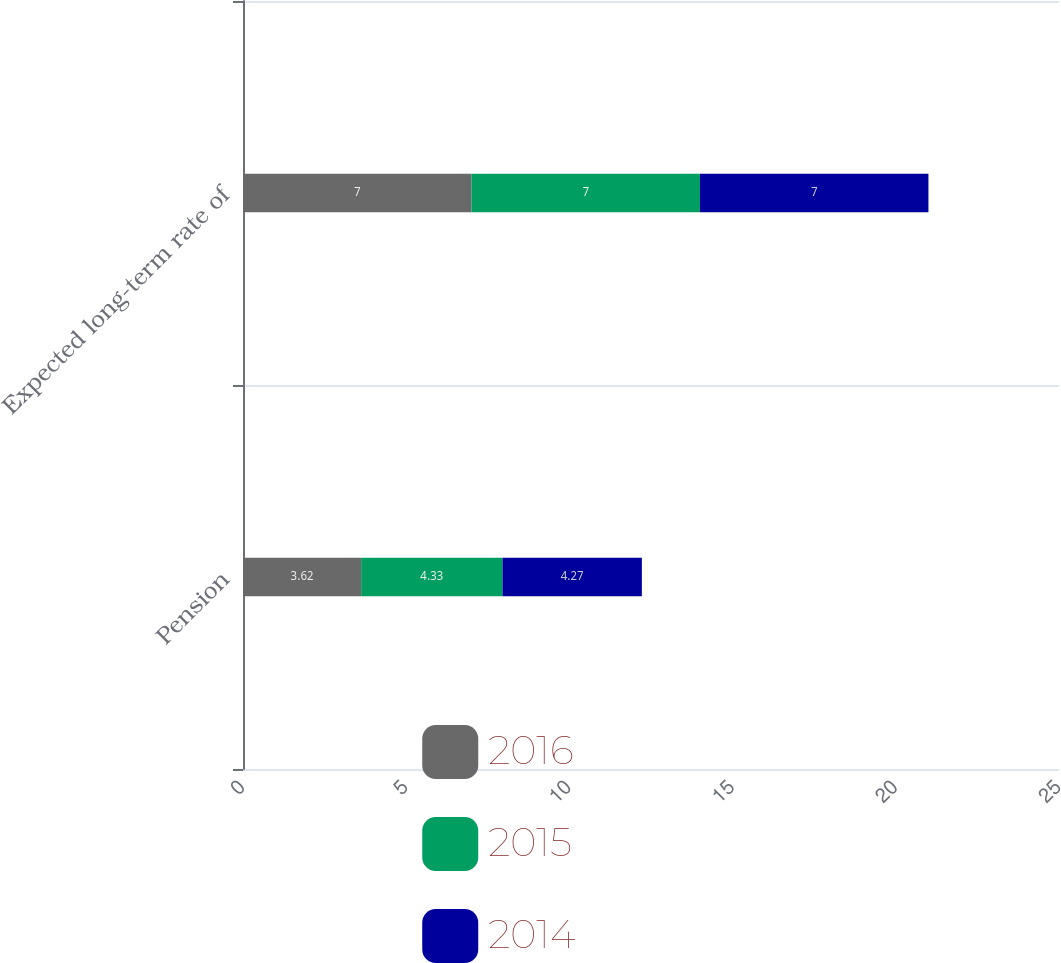<chart> <loc_0><loc_0><loc_500><loc_500><stacked_bar_chart><ecel><fcel>Pension<fcel>Expected long-term rate of<nl><fcel>2016<fcel>3.62<fcel>7<nl><fcel>2015<fcel>4.33<fcel>7<nl><fcel>2014<fcel>4.27<fcel>7<nl></chart> 